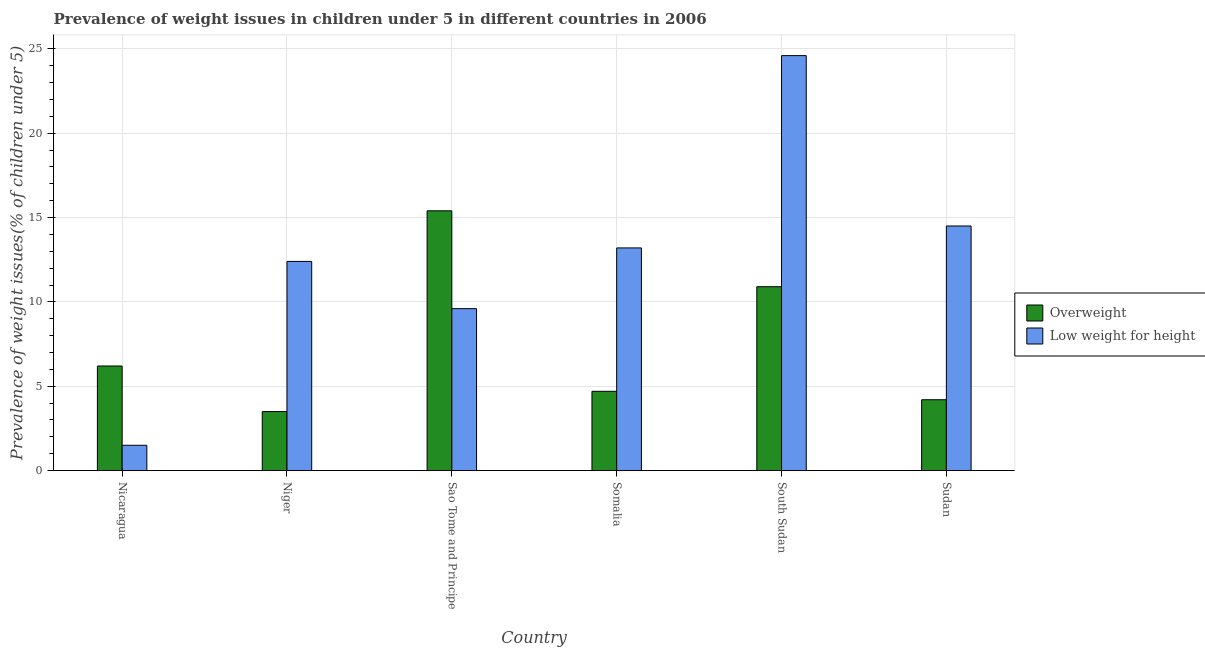Are the number of bars on each tick of the X-axis equal?
Your response must be concise. Yes. How many bars are there on the 5th tick from the left?
Keep it short and to the point. 2. What is the label of the 3rd group of bars from the left?
Make the answer very short. Sao Tome and Principe. In how many cases, is the number of bars for a given country not equal to the number of legend labels?
Your answer should be very brief. 0. What is the percentage of overweight children in Somalia?
Offer a terse response. 4.7. Across all countries, what is the maximum percentage of overweight children?
Your answer should be very brief. 15.4. Across all countries, what is the minimum percentage of overweight children?
Your answer should be very brief. 3.5. In which country was the percentage of overweight children maximum?
Provide a succinct answer. Sao Tome and Principe. In which country was the percentage of underweight children minimum?
Your answer should be compact. Nicaragua. What is the total percentage of underweight children in the graph?
Your answer should be compact. 75.8. What is the difference between the percentage of overweight children in Niger and that in Sudan?
Ensure brevity in your answer.  -0.7. What is the difference between the percentage of underweight children in Niger and the percentage of overweight children in South Sudan?
Keep it short and to the point. 1.5. What is the average percentage of overweight children per country?
Offer a very short reply. 7.48. What is the difference between the percentage of overweight children and percentage of underweight children in Somalia?
Make the answer very short. -8.5. In how many countries, is the percentage of underweight children greater than 21 %?
Ensure brevity in your answer.  1. What is the ratio of the percentage of underweight children in Nicaragua to that in Somalia?
Your answer should be compact. 0.11. Is the percentage of underweight children in Niger less than that in South Sudan?
Keep it short and to the point. Yes. What is the difference between the highest and the second highest percentage of overweight children?
Your response must be concise. 4.5. What is the difference between the highest and the lowest percentage of overweight children?
Your answer should be very brief. 11.9. In how many countries, is the percentage of underweight children greater than the average percentage of underweight children taken over all countries?
Your answer should be very brief. 3. Is the sum of the percentage of overweight children in Nicaragua and Sao Tome and Principe greater than the maximum percentage of underweight children across all countries?
Ensure brevity in your answer.  No. What does the 2nd bar from the left in Sao Tome and Principe represents?
Your answer should be compact. Low weight for height. What does the 1st bar from the right in Sudan represents?
Offer a very short reply. Low weight for height. How many bars are there?
Your answer should be compact. 12. Are all the bars in the graph horizontal?
Offer a terse response. No. How many countries are there in the graph?
Your answer should be compact. 6. Are the values on the major ticks of Y-axis written in scientific E-notation?
Offer a very short reply. No. How many legend labels are there?
Your answer should be compact. 2. What is the title of the graph?
Offer a very short reply. Prevalence of weight issues in children under 5 in different countries in 2006. Does "Constant 2005 US$" appear as one of the legend labels in the graph?
Make the answer very short. No. What is the label or title of the Y-axis?
Provide a succinct answer. Prevalence of weight issues(% of children under 5). What is the Prevalence of weight issues(% of children under 5) of Overweight in Nicaragua?
Ensure brevity in your answer.  6.2. What is the Prevalence of weight issues(% of children under 5) of Low weight for height in Nicaragua?
Your response must be concise. 1.5. What is the Prevalence of weight issues(% of children under 5) in Overweight in Niger?
Ensure brevity in your answer.  3.5. What is the Prevalence of weight issues(% of children under 5) of Low weight for height in Niger?
Provide a short and direct response. 12.4. What is the Prevalence of weight issues(% of children under 5) of Overweight in Sao Tome and Principe?
Offer a terse response. 15.4. What is the Prevalence of weight issues(% of children under 5) of Low weight for height in Sao Tome and Principe?
Offer a terse response. 9.6. What is the Prevalence of weight issues(% of children under 5) in Overweight in Somalia?
Your answer should be very brief. 4.7. What is the Prevalence of weight issues(% of children under 5) of Low weight for height in Somalia?
Offer a terse response. 13.2. What is the Prevalence of weight issues(% of children under 5) in Overweight in South Sudan?
Offer a terse response. 10.9. What is the Prevalence of weight issues(% of children under 5) in Low weight for height in South Sudan?
Offer a very short reply. 24.6. What is the Prevalence of weight issues(% of children under 5) in Overweight in Sudan?
Give a very brief answer. 4.2. Across all countries, what is the maximum Prevalence of weight issues(% of children under 5) in Overweight?
Make the answer very short. 15.4. Across all countries, what is the maximum Prevalence of weight issues(% of children under 5) of Low weight for height?
Keep it short and to the point. 24.6. Across all countries, what is the minimum Prevalence of weight issues(% of children under 5) in Overweight?
Give a very brief answer. 3.5. What is the total Prevalence of weight issues(% of children under 5) in Overweight in the graph?
Provide a succinct answer. 44.9. What is the total Prevalence of weight issues(% of children under 5) of Low weight for height in the graph?
Your answer should be very brief. 75.8. What is the difference between the Prevalence of weight issues(% of children under 5) of Low weight for height in Nicaragua and that in Niger?
Ensure brevity in your answer.  -10.9. What is the difference between the Prevalence of weight issues(% of children under 5) in Overweight in Nicaragua and that in Somalia?
Offer a terse response. 1.5. What is the difference between the Prevalence of weight issues(% of children under 5) of Low weight for height in Nicaragua and that in Somalia?
Keep it short and to the point. -11.7. What is the difference between the Prevalence of weight issues(% of children under 5) in Low weight for height in Nicaragua and that in South Sudan?
Ensure brevity in your answer.  -23.1. What is the difference between the Prevalence of weight issues(% of children under 5) of Overweight in Nicaragua and that in Sudan?
Keep it short and to the point. 2. What is the difference between the Prevalence of weight issues(% of children under 5) of Low weight for height in Nicaragua and that in Sudan?
Give a very brief answer. -13. What is the difference between the Prevalence of weight issues(% of children under 5) of Low weight for height in Niger and that in Sao Tome and Principe?
Your answer should be compact. 2.8. What is the difference between the Prevalence of weight issues(% of children under 5) in Overweight in Niger and that in Somalia?
Make the answer very short. -1.2. What is the difference between the Prevalence of weight issues(% of children under 5) of Low weight for height in Niger and that in Somalia?
Provide a short and direct response. -0.8. What is the difference between the Prevalence of weight issues(% of children under 5) of Overweight in Niger and that in South Sudan?
Provide a succinct answer. -7.4. What is the difference between the Prevalence of weight issues(% of children under 5) of Low weight for height in Niger and that in South Sudan?
Provide a short and direct response. -12.2. What is the difference between the Prevalence of weight issues(% of children under 5) in Overweight in Niger and that in Sudan?
Give a very brief answer. -0.7. What is the difference between the Prevalence of weight issues(% of children under 5) in Overweight in Sao Tome and Principe and that in Somalia?
Provide a succinct answer. 10.7. What is the difference between the Prevalence of weight issues(% of children under 5) in Low weight for height in Sao Tome and Principe and that in South Sudan?
Your response must be concise. -15. What is the difference between the Prevalence of weight issues(% of children under 5) of Low weight for height in Sao Tome and Principe and that in Sudan?
Provide a succinct answer. -4.9. What is the difference between the Prevalence of weight issues(% of children under 5) of Low weight for height in Somalia and that in South Sudan?
Provide a short and direct response. -11.4. What is the difference between the Prevalence of weight issues(% of children under 5) in Overweight in South Sudan and that in Sudan?
Provide a succinct answer. 6.7. What is the difference between the Prevalence of weight issues(% of children under 5) in Low weight for height in South Sudan and that in Sudan?
Ensure brevity in your answer.  10.1. What is the difference between the Prevalence of weight issues(% of children under 5) in Overweight in Nicaragua and the Prevalence of weight issues(% of children under 5) in Low weight for height in Somalia?
Give a very brief answer. -7. What is the difference between the Prevalence of weight issues(% of children under 5) in Overweight in Nicaragua and the Prevalence of weight issues(% of children under 5) in Low weight for height in South Sudan?
Provide a short and direct response. -18.4. What is the difference between the Prevalence of weight issues(% of children under 5) in Overweight in Niger and the Prevalence of weight issues(% of children under 5) in Low weight for height in Sao Tome and Principe?
Give a very brief answer. -6.1. What is the difference between the Prevalence of weight issues(% of children under 5) of Overweight in Niger and the Prevalence of weight issues(% of children under 5) of Low weight for height in South Sudan?
Keep it short and to the point. -21.1. What is the difference between the Prevalence of weight issues(% of children under 5) of Overweight in Niger and the Prevalence of weight issues(% of children under 5) of Low weight for height in Sudan?
Provide a succinct answer. -11. What is the difference between the Prevalence of weight issues(% of children under 5) of Overweight in Sao Tome and Principe and the Prevalence of weight issues(% of children under 5) of Low weight for height in South Sudan?
Your answer should be very brief. -9.2. What is the difference between the Prevalence of weight issues(% of children under 5) in Overweight in Sao Tome and Principe and the Prevalence of weight issues(% of children under 5) in Low weight for height in Sudan?
Give a very brief answer. 0.9. What is the difference between the Prevalence of weight issues(% of children under 5) in Overweight in Somalia and the Prevalence of weight issues(% of children under 5) in Low weight for height in South Sudan?
Offer a terse response. -19.9. What is the difference between the Prevalence of weight issues(% of children under 5) in Overweight in South Sudan and the Prevalence of weight issues(% of children under 5) in Low weight for height in Sudan?
Keep it short and to the point. -3.6. What is the average Prevalence of weight issues(% of children under 5) in Overweight per country?
Ensure brevity in your answer.  7.48. What is the average Prevalence of weight issues(% of children under 5) of Low weight for height per country?
Ensure brevity in your answer.  12.63. What is the difference between the Prevalence of weight issues(% of children under 5) in Overweight and Prevalence of weight issues(% of children under 5) in Low weight for height in Nicaragua?
Offer a terse response. 4.7. What is the difference between the Prevalence of weight issues(% of children under 5) in Overweight and Prevalence of weight issues(% of children under 5) in Low weight for height in Somalia?
Provide a succinct answer. -8.5. What is the difference between the Prevalence of weight issues(% of children under 5) of Overweight and Prevalence of weight issues(% of children under 5) of Low weight for height in South Sudan?
Offer a terse response. -13.7. What is the difference between the Prevalence of weight issues(% of children under 5) in Overweight and Prevalence of weight issues(% of children under 5) in Low weight for height in Sudan?
Your answer should be compact. -10.3. What is the ratio of the Prevalence of weight issues(% of children under 5) of Overweight in Nicaragua to that in Niger?
Offer a terse response. 1.77. What is the ratio of the Prevalence of weight issues(% of children under 5) in Low weight for height in Nicaragua to that in Niger?
Ensure brevity in your answer.  0.12. What is the ratio of the Prevalence of weight issues(% of children under 5) in Overweight in Nicaragua to that in Sao Tome and Principe?
Offer a very short reply. 0.4. What is the ratio of the Prevalence of weight issues(% of children under 5) of Low weight for height in Nicaragua to that in Sao Tome and Principe?
Ensure brevity in your answer.  0.16. What is the ratio of the Prevalence of weight issues(% of children under 5) in Overweight in Nicaragua to that in Somalia?
Provide a succinct answer. 1.32. What is the ratio of the Prevalence of weight issues(% of children under 5) of Low weight for height in Nicaragua to that in Somalia?
Your answer should be very brief. 0.11. What is the ratio of the Prevalence of weight issues(% of children under 5) of Overweight in Nicaragua to that in South Sudan?
Your response must be concise. 0.57. What is the ratio of the Prevalence of weight issues(% of children under 5) of Low weight for height in Nicaragua to that in South Sudan?
Your answer should be compact. 0.06. What is the ratio of the Prevalence of weight issues(% of children under 5) in Overweight in Nicaragua to that in Sudan?
Give a very brief answer. 1.48. What is the ratio of the Prevalence of weight issues(% of children under 5) in Low weight for height in Nicaragua to that in Sudan?
Provide a succinct answer. 0.1. What is the ratio of the Prevalence of weight issues(% of children under 5) in Overweight in Niger to that in Sao Tome and Principe?
Your answer should be very brief. 0.23. What is the ratio of the Prevalence of weight issues(% of children under 5) in Low weight for height in Niger to that in Sao Tome and Principe?
Make the answer very short. 1.29. What is the ratio of the Prevalence of weight issues(% of children under 5) of Overweight in Niger to that in Somalia?
Offer a terse response. 0.74. What is the ratio of the Prevalence of weight issues(% of children under 5) of Low weight for height in Niger to that in Somalia?
Your response must be concise. 0.94. What is the ratio of the Prevalence of weight issues(% of children under 5) of Overweight in Niger to that in South Sudan?
Provide a short and direct response. 0.32. What is the ratio of the Prevalence of weight issues(% of children under 5) of Low weight for height in Niger to that in South Sudan?
Your response must be concise. 0.5. What is the ratio of the Prevalence of weight issues(% of children under 5) of Overweight in Niger to that in Sudan?
Your answer should be very brief. 0.83. What is the ratio of the Prevalence of weight issues(% of children under 5) in Low weight for height in Niger to that in Sudan?
Keep it short and to the point. 0.86. What is the ratio of the Prevalence of weight issues(% of children under 5) in Overweight in Sao Tome and Principe to that in Somalia?
Make the answer very short. 3.28. What is the ratio of the Prevalence of weight issues(% of children under 5) in Low weight for height in Sao Tome and Principe to that in Somalia?
Your answer should be very brief. 0.73. What is the ratio of the Prevalence of weight issues(% of children under 5) in Overweight in Sao Tome and Principe to that in South Sudan?
Give a very brief answer. 1.41. What is the ratio of the Prevalence of weight issues(% of children under 5) of Low weight for height in Sao Tome and Principe to that in South Sudan?
Provide a succinct answer. 0.39. What is the ratio of the Prevalence of weight issues(% of children under 5) of Overweight in Sao Tome and Principe to that in Sudan?
Offer a terse response. 3.67. What is the ratio of the Prevalence of weight issues(% of children under 5) in Low weight for height in Sao Tome and Principe to that in Sudan?
Offer a terse response. 0.66. What is the ratio of the Prevalence of weight issues(% of children under 5) of Overweight in Somalia to that in South Sudan?
Offer a very short reply. 0.43. What is the ratio of the Prevalence of weight issues(% of children under 5) in Low weight for height in Somalia to that in South Sudan?
Your response must be concise. 0.54. What is the ratio of the Prevalence of weight issues(% of children under 5) in Overweight in Somalia to that in Sudan?
Offer a terse response. 1.12. What is the ratio of the Prevalence of weight issues(% of children under 5) of Low weight for height in Somalia to that in Sudan?
Your response must be concise. 0.91. What is the ratio of the Prevalence of weight issues(% of children under 5) of Overweight in South Sudan to that in Sudan?
Give a very brief answer. 2.6. What is the ratio of the Prevalence of weight issues(% of children under 5) of Low weight for height in South Sudan to that in Sudan?
Give a very brief answer. 1.7. What is the difference between the highest and the second highest Prevalence of weight issues(% of children under 5) of Overweight?
Your answer should be very brief. 4.5. What is the difference between the highest and the lowest Prevalence of weight issues(% of children under 5) of Low weight for height?
Provide a succinct answer. 23.1. 